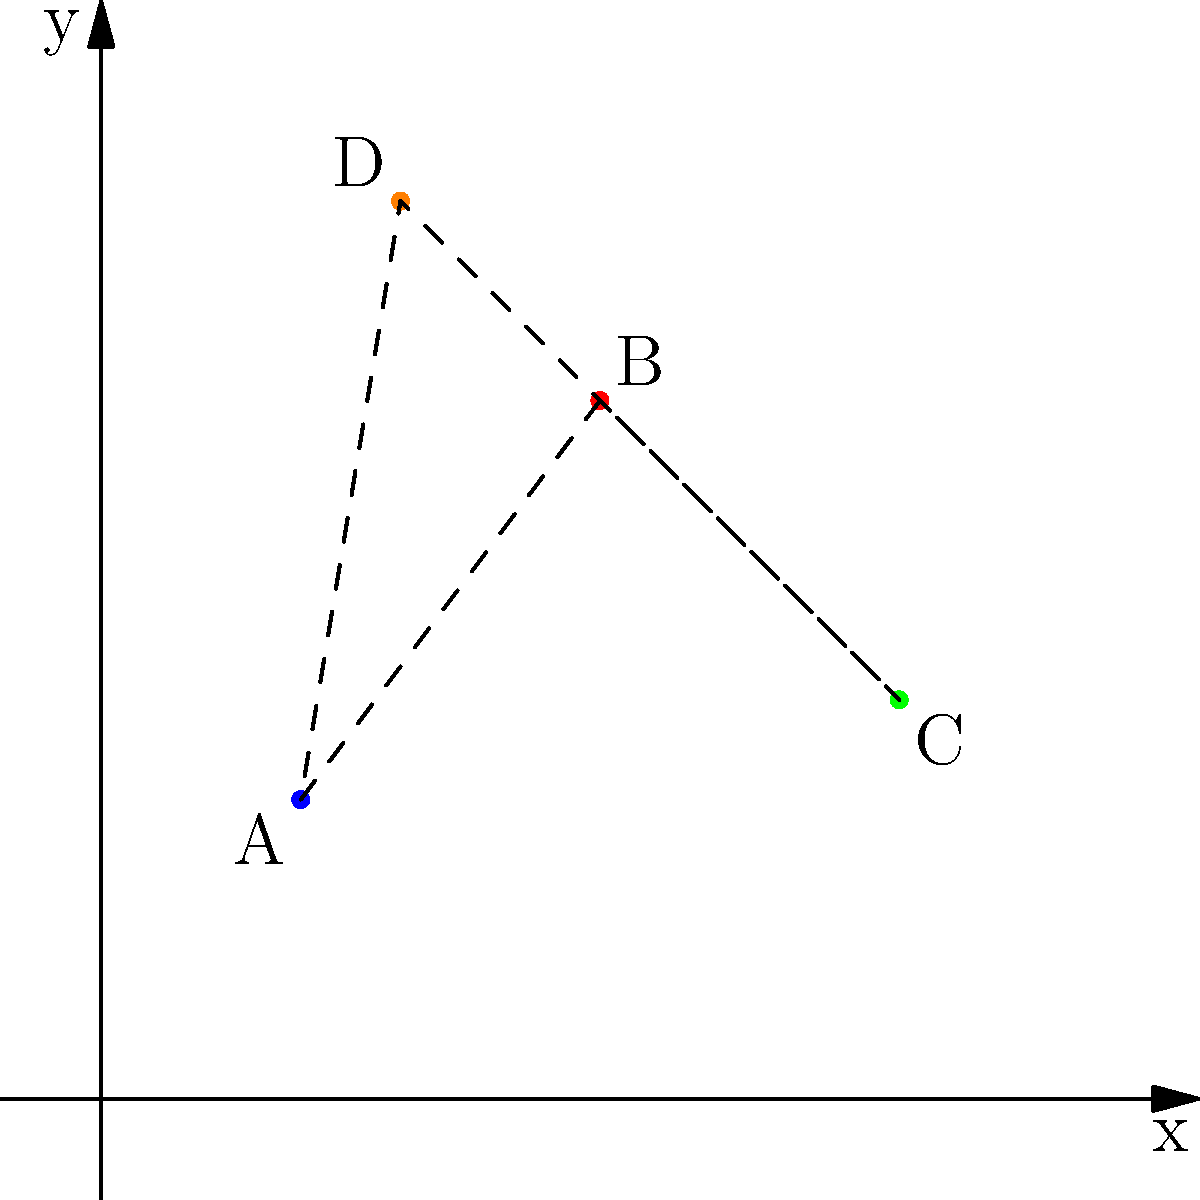As part of planning a youth field trip to historical landmarks, you've plotted four locations on a coordinate plane: A(2,3), B(5,7), C(8,4), and D(3,9). If you connect these points to form a quadrilateral, what is the area of the resulting shape in square units? To find the area of the quadrilateral formed by connecting the four landmark locations, we can use the Shoelace formula (also known as the surveyor's formula). This method is particularly useful for calculating the area of an irregular polygon given the coordinates of its vertices.

Step 1: Order the vertices.
We'll use the order A(2,3), B(5,7), C(8,4), D(3,9).

Step 2: Apply the Shoelace formula.
The formula is:
$$ \text{Area} = \frac{1}{2}|(x_1y_2 + x_2y_3 + x_3y_4 + x_4y_1) - (y_1x_2 + y_2x_3 + y_3x_4 + y_4x_1)| $$

Step 3: Substitute the values.
$$ \text{Area} = \frac{1}{2}|(2 \cdot 7 + 5 \cdot 4 + 8 \cdot 9 + 3 \cdot 3) - (3 \cdot 5 + 7 \cdot 8 + 4 \cdot 3 + 9 \cdot 2)| $$

Step 4: Calculate.
$$ \text{Area} = \frac{1}{2}|(14 + 20 + 72 + 9) - (15 + 56 + 12 + 18)| $$
$$ \text{Area} = \frac{1}{2}|115 - 101| $$
$$ \text{Area} = \frac{1}{2} \cdot 14 = 7 $$

Therefore, the area of the quadrilateral is 7 square units.
Answer: 7 square units 